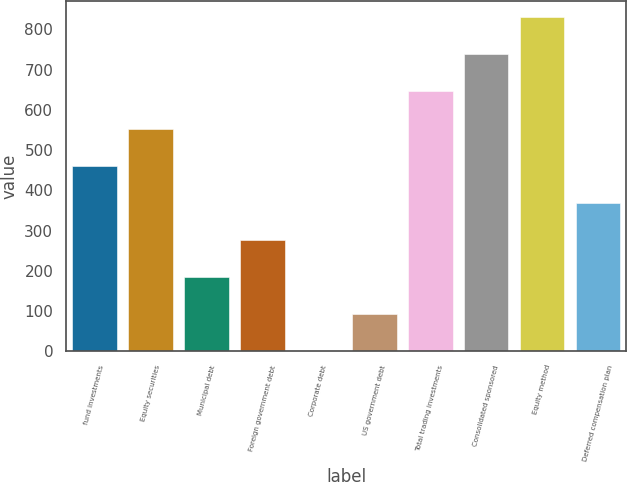Convert chart. <chart><loc_0><loc_0><loc_500><loc_500><bar_chart><fcel>fund investments<fcel>Equity securities<fcel>Municipal debt<fcel>Foreign government debt<fcel>Corporate debt<fcel>US government debt<fcel>Total trading investments<fcel>Consolidated sponsored<fcel>Equity method<fcel>Deferred compensation plan<nl><fcel>461.5<fcel>553.6<fcel>185.2<fcel>277.3<fcel>1<fcel>93.1<fcel>645.7<fcel>737.8<fcel>829.9<fcel>369.4<nl></chart> 